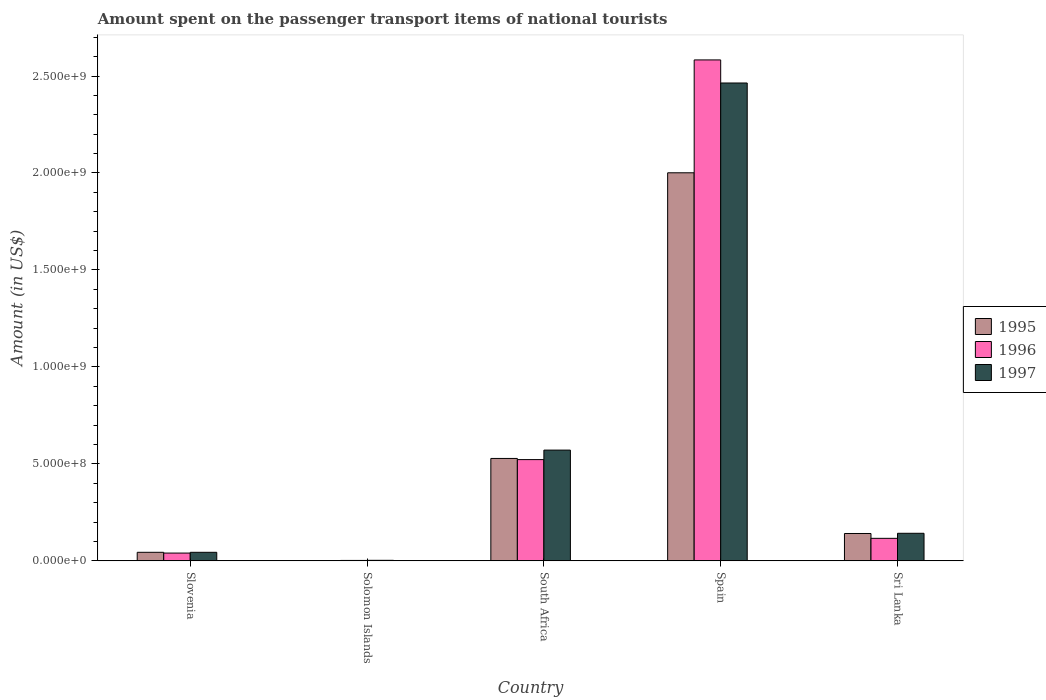How many different coloured bars are there?
Your response must be concise. 3. How many groups of bars are there?
Provide a short and direct response. 5. Are the number of bars on each tick of the X-axis equal?
Provide a succinct answer. Yes. How many bars are there on the 1st tick from the right?
Make the answer very short. 3. What is the label of the 4th group of bars from the left?
Give a very brief answer. Spain. In how many cases, is the number of bars for a given country not equal to the number of legend labels?
Your answer should be very brief. 0. What is the amount spent on the passenger transport items of national tourists in 1996 in Sri Lanka?
Your answer should be compact. 1.16e+08. Across all countries, what is the maximum amount spent on the passenger transport items of national tourists in 1997?
Keep it short and to the point. 2.46e+09. Across all countries, what is the minimum amount spent on the passenger transport items of national tourists in 1997?
Your response must be concise. 2.60e+06. In which country was the amount spent on the passenger transport items of national tourists in 1996 minimum?
Give a very brief answer. Solomon Islands. What is the total amount spent on the passenger transport items of national tourists in 1997 in the graph?
Offer a terse response. 3.22e+09. What is the difference between the amount spent on the passenger transport items of national tourists in 1996 in South Africa and that in Sri Lanka?
Keep it short and to the point. 4.06e+08. What is the difference between the amount spent on the passenger transport items of national tourists in 1997 in Slovenia and the amount spent on the passenger transport items of national tourists in 1995 in Sri Lanka?
Make the answer very short. -9.70e+07. What is the average amount spent on the passenger transport items of national tourists in 1997 per country?
Offer a very short reply. 6.45e+08. What is the difference between the amount spent on the passenger transport items of national tourists of/in 1997 and amount spent on the passenger transport items of national tourists of/in 1995 in South Africa?
Your answer should be very brief. 4.30e+07. What is the ratio of the amount spent on the passenger transport items of national tourists in 1995 in Solomon Islands to that in South Africa?
Ensure brevity in your answer.  0. Is the difference between the amount spent on the passenger transport items of national tourists in 1997 in Solomon Islands and Sri Lanka greater than the difference between the amount spent on the passenger transport items of national tourists in 1995 in Solomon Islands and Sri Lanka?
Offer a very short reply. Yes. What is the difference between the highest and the second highest amount spent on the passenger transport items of national tourists in 1995?
Provide a succinct answer. 1.47e+09. What is the difference between the highest and the lowest amount spent on the passenger transport items of national tourists in 1996?
Provide a short and direct response. 2.58e+09. Is the sum of the amount spent on the passenger transport items of national tourists in 1997 in Slovenia and Spain greater than the maximum amount spent on the passenger transport items of national tourists in 1996 across all countries?
Offer a terse response. No. Is it the case that in every country, the sum of the amount spent on the passenger transport items of national tourists in 1996 and amount spent on the passenger transport items of national tourists in 1995 is greater than the amount spent on the passenger transport items of national tourists in 1997?
Your answer should be very brief. Yes. What is the difference between two consecutive major ticks on the Y-axis?
Keep it short and to the point. 5.00e+08. How many legend labels are there?
Give a very brief answer. 3. How are the legend labels stacked?
Give a very brief answer. Vertical. What is the title of the graph?
Your answer should be very brief. Amount spent on the passenger transport items of national tourists. What is the label or title of the X-axis?
Your answer should be compact. Country. What is the label or title of the Y-axis?
Give a very brief answer. Amount (in US$). What is the Amount (in US$) in 1995 in Slovenia?
Make the answer very short. 4.40e+07. What is the Amount (in US$) of 1996 in Slovenia?
Provide a succinct answer. 4.00e+07. What is the Amount (in US$) of 1997 in Slovenia?
Provide a succinct answer. 4.40e+07. What is the Amount (in US$) in 1995 in Solomon Islands?
Ensure brevity in your answer.  1.40e+06. What is the Amount (in US$) in 1996 in Solomon Islands?
Keep it short and to the point. 2.10e+06. What is the Amount (in US$) of 1997 in Solomon Islands?
Your response must be concise. 2.60e+06. What is the Amount (in US$) in 1995 in South Africa?
Your response must be concise. 5.28e+08. What is the Amount (in US$) of 1996 in South Africa?
Your answer should be compact. 5.22e+08. What is the Amount (in US$) of 1997 in South Africa?
Provide a succinct answer. 5.71e+08. What is the Amount (in US$) of 1995 in Spain?
Make the answer very short. 2.00e+09. What is the Amount (in US$) in 1996 in Spain?
Your answer should be compact. 2.58e+09. What is the Amount (in US$) in 1997 in Spain?
Provide a succinct answer. 2.46e+09. What is the Amount (in US$) in 1995 in Sri Lanka?
Keep it short and to the point. 1.41e+08. What is the Amount (in US$) of 1996 in Sri Lanka?
Your response must be concise. 1.16e+08. What is the Amount (in US$) in 1997 in Sri Lanka?
Give a very brief answer. 1.42e+08. Across all countries, what is the maximum Amount (in US$) of 1995?
Your response must be concise. 2.00e+09. Across all countries, what is the maximum Amount (in US$) in 1996?
Keep it short and to the point. 2.58e+09. Across all countries, what is the maximum Amount (in US$) of 1997?
Ensure brevity in your answer.  2.46e+09. Across all countries, what is the minimum Amount (in US$) in 1995?
Provide a short and direct response. 1.40e+06. Across all countries, what is the minimum Amount (in US$) of 1996?
Offer a terse response. 2.10e+06. Across all countries, what is the minimum Amount (in US$) in 1997?
Give a very brief answer. 2.60e+06. What is the total Amount (in US$) of 1995 in the graph?
Your answer should be compact. 2.72e+09. What is the total Amount (in US$) of 1996 in the graph?
Ensure brevity in your answer.  3.26e+09. What is the total Amount (in US$) in 1997 in the graph?
Ensure brevity in your answer.  3.22e+09. What is the difference between the Amount (in US$) in 1995 in Slovenia and that in Solomon Islands?
Your response must be concise. 4.26e+07. What is the difference between the Amount (in US$) of 1996 in Slovenia and that in Solomon Islands?
Offer a terse response. 3.79e+07. What is the difference between the Amount (in US$) of 1997 in Slovenia and that in Solomon Islands?
Make the answer very short. 4.14e+07. What is the difference between the Amount (in US$) in 1995 in Slovenia and that in South Africa?
Ensure brevity in your answer.  -4.84e+08. What is the difference between the Amount (in US$) in 1996 in Slovenia and that in South Africa?
Provide a succinct answer. -4.82e+08. What is the difference between the Amount (in US$) in 1997 in Slovenia and that in South Africa?
Keep it short and to the point. -5.27e+08. What is the difference between the Amount (in US$) in 1995 in Slovenia and that in Spain?
Your answer should be compact. -1.96e+09. What is the difference between the Amount (in US$) of 1996 in Slovenia and that in Spain?
Your answer should be very brief. -2.54e+09. What is the difference between the Amount (in US$) in 1997 in Slovenia and that in Spain?
Keep it short and to the point. -2.42e+09. What is the difference between the Amount (in US$) in 1995 in Slovenia and that in Sri Lanka?
Offer a very short reply. -9.70e+07. What is the difference between the Amount (in US$) of 1996 in Slovenia and that in Sri Lanka?
Your response must be concise. -7.60e+07. What is the difference between the Amount (in US$) in 1997 in Slovenia and that in Sri Lanka?
Ensure brevity in your answer.  -9.80e+07. What is the difference between the Amount (in US$) in 1995 in Solomon Islands and that in South Africa?
Give a very brief answer. -5.27e+08. What is the difference between the Amount (in US$) of 1996 in Solomon Islands and that in South Africa?
Your answer should be very brief. -5.20e+08. What is the difference between the Amount (in US$) in 1997 in Solomon Islands and that in South Africa?
Keep it short and to the point. -5.68e+08. What is the difference between the Amount (in US$) in 1995 in Solomon Islands and that in Spain?
Offer a very short reply. -2.00e+09. What is the difference between the Amount (in US$) in 1996 in Solomon Islands and that in Spain?
Offer a terse response. -2.58e+09. What is the difference between the Amount (in US$) of 1997 in Solomon Islands and that in Spain?
Offer a very short reply. -2.46e+09. What is the difference between the Amount (in US$) in 1995 in Solomon Islands and that in Sri Lanka?
Offer a very short reply. -1.40e+08. What is the difference between the Amount (in US$) of 1996 in Solomon Islands and that in Sri Lanka?
Make the answer very short. -1.14e+08. What is the difference between the Amount (in US$) of 1997 in Solomon Islands and that in Sri Lanka?
Give a very brief answer. -1.39e+08. What is the difference between the Amount (in US$) of 1995 in South Africa and that in Spain?
Keep it short and to the point. -1.47e+09. What is the difference between the Amount (in US$) in 1996 in South Africa and that in Spain?
Ensure brevity in your answer.  -2.06e+09. What is the difference between the Amount (in US$) of 1997 in South Africa and that in Spain?
Your response must be concise. -1.89e+09. What is the difference between the Amount (in US$) of 1995 in South Africa and that in Sri Lanka?
Your answer should be compact. 3.87e+08. What is the difference between the Amount (in US$) in 1996 in South Africa and that in Sri Lanka?
Offer a very short reply. 4.06e+08. What is the difference between the Amount (in US$) of 1997 in South Africa and that in Sri Lanka?
Keep it short and to the point. 4.29e+08. What is the difference between the Amount (in US$) of 1995 in Spain and that in Sri Lanka?
Ensure brevity in your answer.  1.86e+09. What is the difference between the Amount (in US$) in 1996 in Spain and that in Sri Lanka?
Offer a very short reply. 2.47e+09. What is the difference between the Amount (in US$) in 1997 in Spain and that in Sri Lanka?
Provide a succinct answer. 2.32e+09. What is the difference between the Amount (in US$) of 1995 in Slovenia and the Amount (in US$) of 1996 in Solomon Islands?
Keep it short and to the point. 4.19e+07. What is the difference between the Amount (in US$) of 1995 in Slovenia and the Amount (in US$) of 1997 in Solomon Islands?
Provide a succinct answer. 4.14e+07. What is the difference between the Amount (in US$) in 1996 in Slovenia and the Amount (in US$) in 1997 in Solomon Islands?
Your answer should be very brief. 3.74e+07. What is the difference between the Amount (in US$) in 1995 in Slovenia and the Amount (in US$) in 1996 in South Africa?
Your answer should be very brief. -4.78e+08. What is the difference between the Amount (in US$) in 1995 in Slovenia and the Amount (in US$) in 1997 in South Africa?
Your answer should be compact. -5.27e+08. What is the difference between the Amount (in US$) of 1996 in Slovenia and the Amount (in US$) of 1997 in South Africa?
Keep it short and to the point. -5.31e+08. What is the difference between the Amount (in US$) in 1995 in Slovenia and the Amount (in US$) in 1996 in Spain?
Ensure brevity in your answer.  -2.54e+09. What is the difference between the Amount (in US$) of 1995 in Slovenia and the Amount (in US$) of 1997 in Spain?
Your response must be concise. -2.42e+09. What is the difference between the Amount (in US$) in 1996 in Slovenia and the Amount (in US$) in 1997 in Spain?
Make the answer very short. -2.42e+09. What is the difference between the Amount (in US$) in 1995 in Slovenia and the Amount (in US$) in 1996 in Sri Lanka?
Ensure brevity in your answer.  -7.20e+07. What is the difference between the Amount (in US$) of 1995 in Slovenia and the Amount (in US$) of 1997 in Sri Lanka?
Offer a terse response. -9.80e+07. What is the difference between the Amount (in US$) of 1996 in Slovenia and the Amount (in US$) of 1997 in Sri Lanka?
Make the answer very short. -1.02e+08. What is the difference between the Amount (in US$) in 1995 in Solomon Islands and the Amount (in US$) in 1996 in South Africa?
Give a very brief answer. -5.21e+08. What is the difference between the Amount (in US$) in 1995 in Solomon Islands and the Amount (in US$) in 1997 in South Africa?
Provide a short and direct response. -5.70e+08. What is the difference between the Amount (in US$) of 1996 in Solomon Islands and the Amount (in US$) of 1997 in South Africa?
Your response must be concise. -5.69e+08. What is the difference between the Amount (in US$) of 1995 in Solomon Islands and the Amount (in US$) of 1996 in Spain?
Your answer should be compact. -2.58e+09. What is the difference between the Amount (in US$) of 1995 in Solomon Islands and the Amount (in US$) of 1997 in Spain?
Keep it short and to the point. -2.46e+09. What is the difference between the Amount (in US$) of 1996 in Solomon Islands and the Amount (in US$) of 1997 in Spain?
Your answer should be compact. -2.46e+09. What is the difference between the Amount (in US$) in 1995 in Solomon Islands and the Amount (in US$) in 1996 in Sri Lanka?
Your answer should be very brief. -1.15e+08. What is the difference between the Amount (in US$) in 1995 in Solomon Islands and the Amount (in US$) in 1997 in Sri Lanka?
Ensure brevity in your answer.  -1.41e+08. What is the difference between the Amount (in US$) in 1996 in Solomon Islands and the Amount (in US$) in 1997 in Sri Lanka?
Keep it short and to the point. -1.40e+08. What is the difference between the Amount (in US$) in 1995 in South Africa and the Amount (in US$) in 1996 in Spain?
Keep it short and to the point. -2.06e+09. What is the difference between the Amount (in US$) in 1995 in South Africa and the Amount (in US$) in 1997 in Spain?
Offer a terse response. -1.94e+09. What is the difference between the Amount (in US$) in 1996 in South Africa and the Amount (in US$) in 1997 in Spain?
Your response must be concise. -1.94e+09. What is the difference between the Amount (in US$) in 1995 in South Africa and the Amount (in US$) in 1996 in Sri Lanka?
Keep it short and to the point. 4.12e+08. What is the difference between the Amount (in US$) of 1995 in South Africa and the Amount (in US$) of 1997 in Sri Lanka?
Make the answer very short. 3.86e+08. What is the difference between the Amount (in US$) in 1996 in South Africa and the Amount (in US$) in 1997 in Sri Lanka?
Provide a succinct answer. 3.80e+08. What is the difference between the Amount (in US$) in 1995 in Spain and the Amount (in US$) in 1996 in Sri Lanka?
Provide a short and direct response. 1.88e+09. What is the difference between the Amount (in US$) in 1995 in Spain and the Amount (in US$) in 1997 in Sri Lanka?
Your response must be concise. 1.86e+09. What is the difference between the Amount (in US$) in 1996 in Spain and the Amount (in US$) in 1997 in Sri Lanka?
Provide a short and direct response. 2.44e+09. What is the average Amount (in US$) of 1995 per country?
Give a very brief answer. 5.43e+08. What is the average Amount (in US$) in 1996 per country?
Give a very brief answer. 6.53e+08. What is the average Amount (in US$) of 1997 per country?
Your response must be concise. 6.45e+08. What is the difference between the Amount (in US$) of 1995 and Amount (in US$) of 1996 in Slovenia?
Provide a short and direct response. 4.00e+06. What is the difference between the Amount (in US$) of 1996 and Amount (in US$) of 1997 in Slovenia?
Your response must be concise. -4.00e+06. What is the difference between the Amount (in US$) of 1995 and Amount (in US$) of 1996 in Solomon Islands?
Offer a very short reply. -7.00e+05. What is the difference between the Amount (in US$) of 1995 and Amount (in US$) of 1997 in Solomon Islands?
Give a very brief answer. -1.20e+06. What is the difference between the Amount (in US$) of 1996 and Amount (in US$) of 1997 in Solomon Islands?
Make the answer very short. -5.00e+05. What is the difference between the Amount (in US$) of 1995 and Amount (in US$) of 1997 in South Africa?
Offer a very short reply. -4.30e+07. What is the difference between the Amount (in US$) in 1996 and Amount (in US$) in 1997 in South Africa?
Provide a short and direct response. -4.90e+07. What is the difference between the Amount (in US$) of 1995 and Amount (in US$) of 1996 in Spain?
Offer a very short reply. -5.82e+08. What is the difference between the Amount (in US$) of 1995 and Amount (in US$) of 1997 in Spain?
Your response must be concise. -4.63e+08. What is the difference between the Amount (in US$) of 1996 and Amount (in US$) of 1997 in Spain?
Offer a very short reply. 1.19e+08. What is the difference between the Amount (in US$) in 1995 and Amount (in US$) in 1996 in Sri Lanka?
Your response must be concise. 2.50e+07. What is the difference between the Amount (in US$) in 1996 and Amount (in US$) in 1997 in Sri Lanka?
Ensure brevity in your answer.  -2.60e+07. What is the ratio of the Amount (in US$) of 1995 in Slovenia to that in Solomon Islands?
Ensure brevity in your answer.  31.43. What is the ratio of the Amount (in US$) in 1996 in Slovenia to that in Solomon Islands?
Offer a terse response. 19.05. What is the ratio of the Amount (in US$) of 1997 in Slovenia to that in Solomon Islands?
Keep it short and to the point. 16.92. What is the ratio of the Amount (in US$) of 1995 in Slovenia to that in South Africa?
Give a very brief answer. 0.08. What is the ratio of the Amount (in US$) in 1996 in Slovenia to that in South Africa?
Give a very brief answer. 0.08. What is the ratio of the Amount (in US$) of 1997 in Slovenia to that in South Africa?
Ensure brevity in your answer.  0.08. What is the ratio of the Amount (in US$) in 1995 in Slovenia to that in Spain?
Your answer should be very brief. 0.02. What is the ratio of the Amount (in US$) in 1996 in Slovenia to that in Spain?
Ensure brevity in your answer.  0.02. What is the ratio of the Amount (in US$) of 1997 in Slovenia to that in Spain?
Your answer should be compact. 0.02. What is the ratio of the Amount (in US$) in 1995 in Slovenia to that in Sri Lanka?
Give a very brief answer. 0.31. What is the ratio of the Amount (in US$) in 1996 in Slovenia to that in Sri Lanka?
Your answer should be compact. 0.34. What is the ratio of the Amount (in US$) of 1997 in Slovenia to that in Sri Lanka?
Offer a very short reply. 0.31. What is the ratio of the Amount (in US$) of 1995 in Solomon Islands to that in South Africa?
Provide a short and direct response. 0. What is the ratio of the Amount (in US$) of 1996 in Solomon Islands to that in South Africa?
Your answer should be compact. 0. What is the ratio of the Amount (in US$) of 1997 in Solomon Islands to that in South Africa?
Your response must be concise. 0. What is the ratio of the Amount (in US$) in 1995 in Solomon Islands to that in Spain?
Make the answer very short. 0. What is the ratio of the Amount (in US$) of 1996 in Solomon Islands to that in Spain?
Make the answer very short. 0. What is the ratio of the Amount (in US$) in 1997 in Solomon Islands to that in Spain?
Provide a short and direct response. 0. What is the ratio of the Amount (in US$) of 1995 in Solomon Islands to that in Sri Lanka?
Offer a terse response. 0.01. What is the ratio of the Amount (in US$) in 1996 in Solomon Islands to that in Sri Lanka?
Offer a terse response. 0.02. What is the ratio of the Amount (in US$) of 1997 in Solomon Islands to that in Sri Lanka?
Offer a terse response. 0.02. What is the ratio of the Amount (in US$) in 1995 in South Africa to that in Spain?
Keep it short and to the point. 0.26. What is the ratio of the Amount (in US$) of 1996 in South Africa to that in Spain?
Keep it short and to the point. 0.2. What is the ratio of the Amount (in US$) in 1997 in South Africa to that in Spain?
Keep it short and to the point. 0.23. What is the ratio of the Amount (in US$) of 1995 in South Africa to that in Sri Lanka?
Provide a succinct answer. 3.74. What is the ratio of the Amount (in US$) of 1996 in South Africa to that in Sri Lanka?
Keep it short and to the point. 4.5. What is the ratio of the Amount (in US$) in 1997 in South Africa to that in Sri Lanka?
Your answer should be very brief. 4.02. What is the ratio of the Amount (in US$) of 1995 in Spain to that in Sri Lanka?
Provide a succinct answer. 14.19. What is the ratio of the Amount (in US$) in 1996 in Spain to that in Sri Lanka?
Your response must be concise. 22.27. What is the ratio of the Amount (in US$) of 1997 in Spain to that in Sri Lanka?
Provide a succinct answer. 17.35. What is the difference between the highest and the second highest Amount (in US$) of 1995?
Give a very brief answer. 1.47e+09. What is the difference between the highest and the second highest Amount (in US$) in 1996?
Keep it short and to the point. 2.06e+09. What is the difference between the highest and the second highest Amount (in US$) of 1997?
Make the answer very short. 1.89e+09. What is the difference between the highest and the lowest Amount (in US$) in 1995?
Offer a very short reply. 2.00e+09. What is the difference between the highest and the lowest Amount (in US$) of 1996?
Provide a short and direct response. 2.58e+09. What is the difference between the highest and the lowest Amount (in US$) of 1997?
Offer a very short reply. 2.46e+09. 